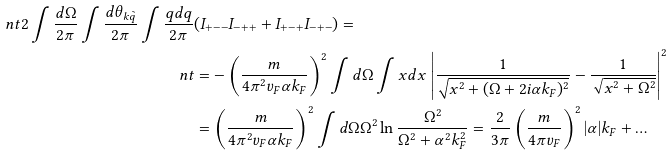Convert formula to latex. <formula><loc_0><loc_0><loc_500><loc_500>\ n t 2 \int \frac { d \Omega } { 2 \pi } \int \frac { d \theta _ { k \tilde { q } } } { 2 \pi } \int \frac { q d q } { 2 \pi } & ( I _ { + - - } I _ { - + + } + I _ { + - + } I _ { - + - } ) = \\ \ n t & = - \left ( \frac { m } { 4 \pi ^ { 2 } v _ { F } \alpha k _ { F } } \right ) ^ { 2 } \int d \Omega \int x d x \, \left | \frac { 1 } { \sqrt { x ^ { 2 } + ( \Omega + 2 i \alpha k _ { F } ) ^ { 2 } } } - \frac { 1 } { \sqrt { x ^ { 2 } + \Omega ^ { 2 } } } \right | ^ { 2 } \\ & = \left ( \frac { m } { 4 \pi ^ { 2 } v _ { F } \alpha k _ { F } } \right ) ^ { 2 } \int d \Omega \Omega ^ { 2 } \ln \frac { \Omega ^ { 2 } } { \Omega ^ { 2 } + \alpha ^ { 2 } k _ { F } ^ { 2 } } = \frac { 2 } { 3 \pi } \left ( \frac { m } { 4 \pi v _ { F } } \right ) ^ { 2 } | \alpha | k _ { F } + \dots</formula> 